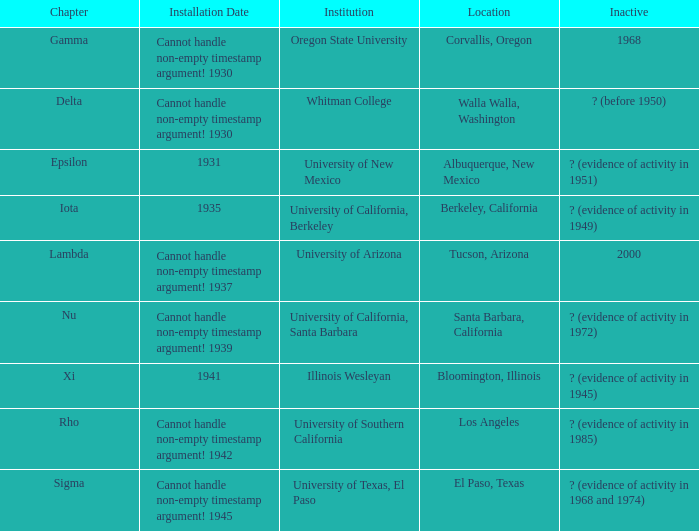What does the inactive state for University of Texas, El Paso?  ? (evidence of activity in 1968 and 1974). 